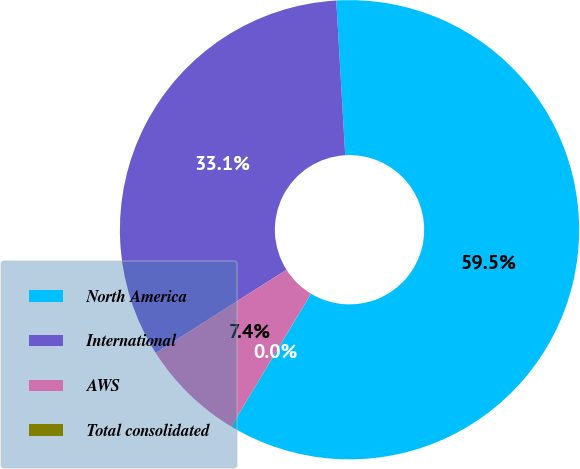<chart> <loc_0><loc_0><loc_500><loc_500><pie_chart><fcel>North America<fcel>International<fcel>AWS<fcel>Total consolidated<nl><fcel>59.53%<fcel>33.09%<fcel>7.36%<fcel>0.02%<nl></chart> 